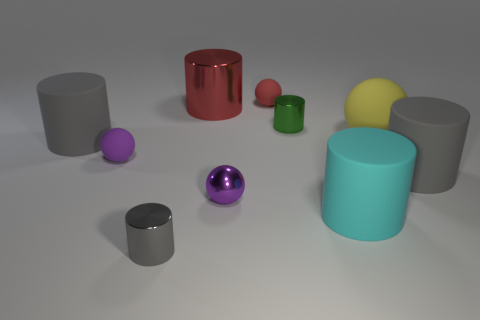There is a small shiny thing on the left side of the big shiny cylinder; does it have the same color as the cylinder that is on the right side of the large cyan rubber thing?
Your answer should be very brief. Yes. There is a big cyan object; how many rubber balls are on the left side of it?
Your answer should be compact. 2. What material is the other small sphere that is the same color as the small metallic ball?
Your answer should be compact. Rubber. Are there any big red metallic things of the same shape as the tiny green metal thing?
Ensure brevity in your answer.  Yes. Do the large gray thing that is right of the tiny metallic sphere and the small purple object right of the purple rubber object have the same material?
Ensure brevity in your answer.  No. There is a gray matte object in front of the gray matte cylinder that is to the left of the tiny ball behind the large sphere; what size is it?
Offer a very short reply. Large. There is a gray cylinder that is the same size as the red rubber ball; what is it made of?
Your response must be concise. Metal. Are there any cyan objects that have the same size as the gray shiny cylinder?
Keep it short and to the point. No. Does the big metallic object have the same shape as the big yellow object?
Your answer should be compact. No. There is a gray cylinder behind the big gray thing to the right of the large red cylinder; are there any gray things in front of it?
Your answer should be very brief. Yes. 